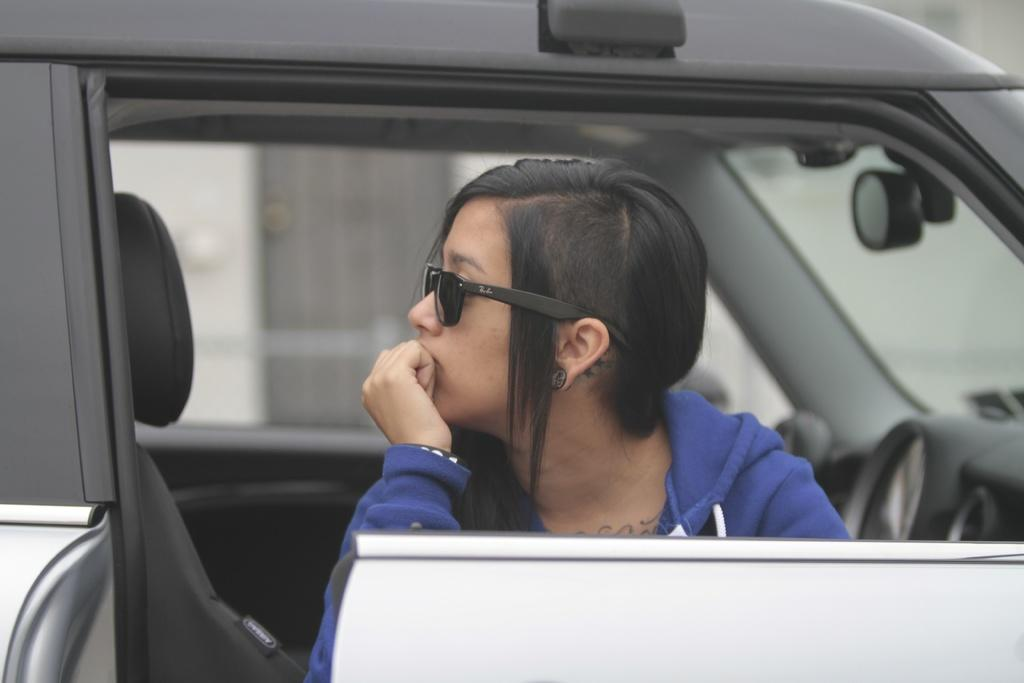What is the person in the image doing? The person is sitting in a car. What can be seen in the background of the image? There is a wall and a door in the background of the image. How many friends are holding sticks in the image? There are no friends or sticks present in the image. 